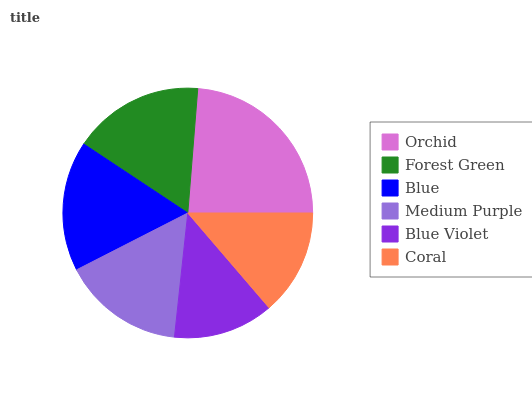Is Blue Violet the minimum?
Answer yes or no. Yes. Is Orchid the maximum?
Answer yes or no. Yes. Is Forest Green the minimum?
Answer yes or no. No. Is Forest Green the maximum?
Answer yes or no. No. Is Orchid greater than Forest Green?
Answer yes or no. Yes. Is Forest Green less than Orchid?
Answer yes or no. Yes. Is Forest Green greater than Orchid?
Answer yes or no. No. Is Orchid less than Forest Green?
Answer yes or no. No. Is Blue the high median?
Answer yes or no. Yes. Is Medium Purple the low median?
Answer yes or no. Yes. Is Coral the high median?
Answer yes or no. No. Is Forest Green the low median?
Answer yes or no. No. 